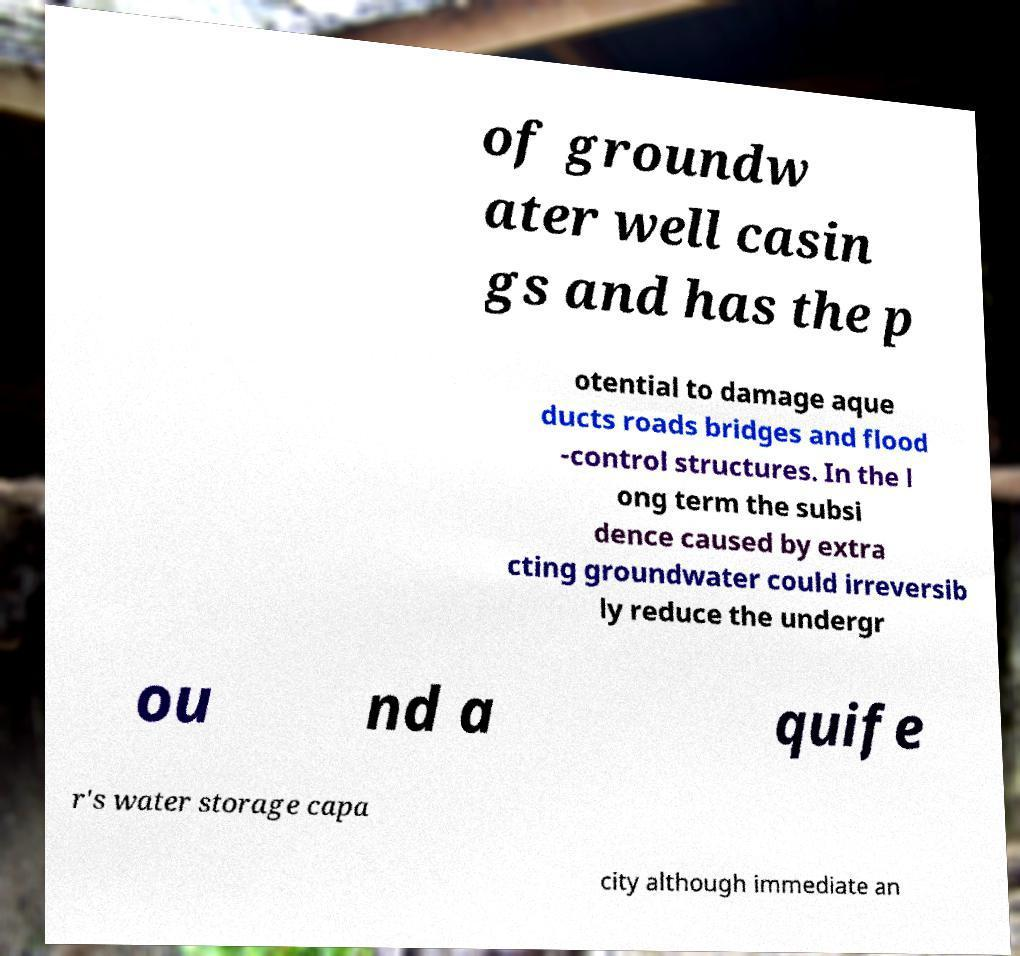I need the written content from this picture converted into text. Can you do that? of groundw ater well casin gs and has the p otential to damage aque ducts roads bridges and flood -control structures. In the l ong term the subsi dence caused by extra cting groundwater could irreversib ly reduce the undergr ou nd a quife r's water storage capa city although immediate an 